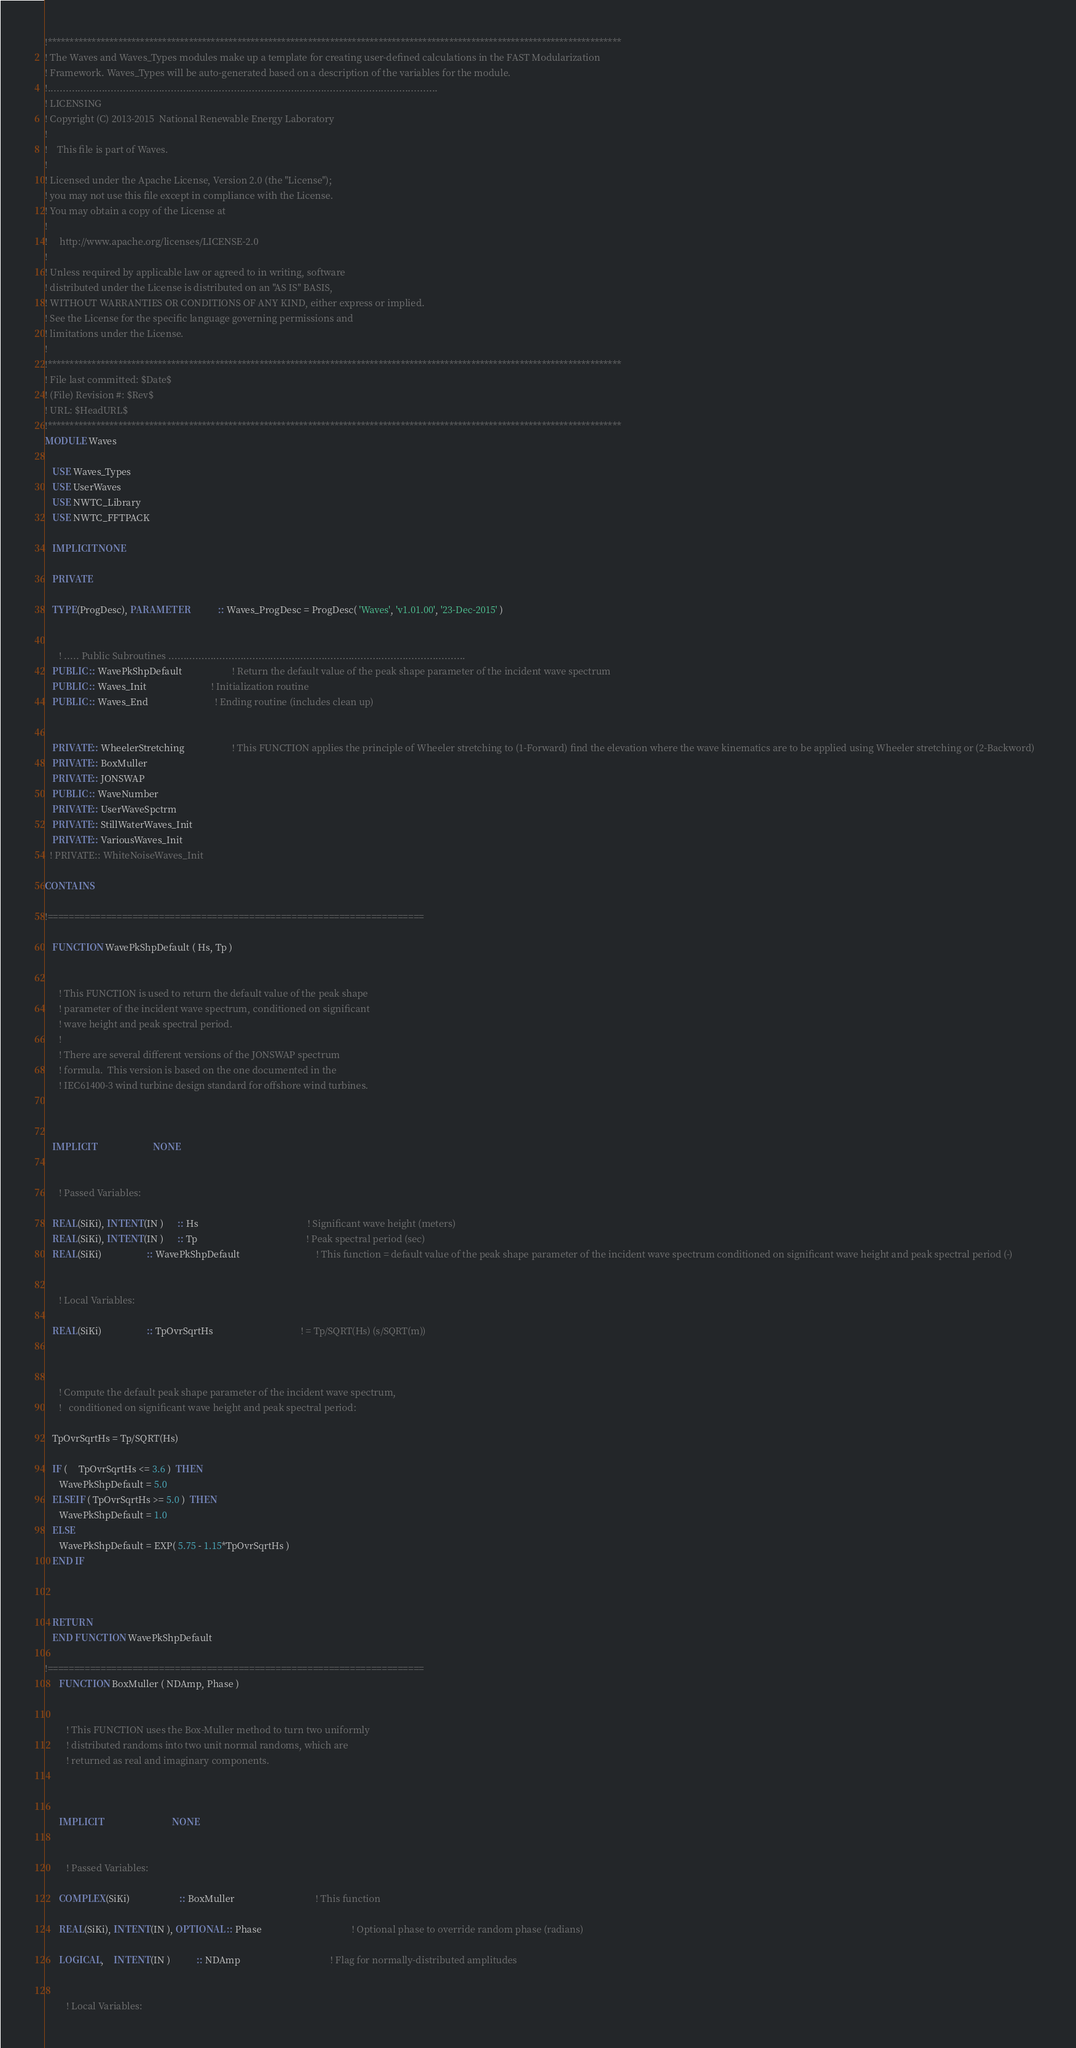<code> <loc_0><loc_0><loc_500><loc_500><_FORTRAN_>!**********************************************************************************************************************************
! The Waves and Waves_Types modules make up a template for creating user-defined calculations in the FAST Modularization 
! Framework. Waves_Types will be auto-generated based on a description of the variables for the module.
!..................................................................................................................................
! LICENSING
! Copyright (C) 2013-2015  National Renewable Energy Laboratory
!
!    This file is part of Waves.
!
! Licensed under the Apache License, Version 2.0 (the "License");
! you may not use this file except in compliance with the License.
! You may obtain a copy of the License at
!
!     http://www.apache.org/licenses/LICENSE-2.0
!
! Unless required by applicable law or agreed to in writing, software
! distributed under the License is distributed on an "AS IS" BASIS,
! WITHOUT WARRANTIES OR CONDITIONS OF ANY KIND, either express or implied.
! See the License for the specific language governing permissions and
! limitations under the License.
!    
!**********************************************************************************************************************************
! File last committed: $Date$
! (File) Revision #: $Rev$
! URL: $HeadURL$
!**********************************************************************************************************************************
MODULE Waves

   USE Waves_Types  
   USE UserWaves
   USE NWTC_Library
   USE NWTC_FFTPACK
      
   IMPLICIT NONE
   
   PRIVATE

   TYPE(ProgDesc), PARAMETER            :: Waves_ProgDesc = ProgDesc( 'Waves', 'v1.01.00', '23-Dec-2015' )

   
      ! ..... Public Subroutines ...................................................................................................
   PUBLIC :: WavePkShpDefault                     ! Return the default value of the peak shape parameter of the incident wave spectrum
   PUBLIC :: Waves_Init                           ! Initialization routine
   PUBLIC :: Waves_End                            ! Ending routine (includes clean up)
            
   
   PRIVATE:: WheelerStretching                    ! This FUNCTION applies the principle of Wheeler stretching to (1-Forward) find the elevation where the wave kinematics are to be applied using Wheeler stretching or (2-Backword)   
   PRIVATE:: BoxMuller
   PRIVATE:: JONSWAP
   PUBLIC :: WaveNumber
   PRIVATE:: UserWaveSpctrm   
   PRIVATE:: StillWaterWaves_Init
   PRIVATE:: VariousWaves_Init
  ! PRIVATE:: WhiteNoiseWaves_Init

CONTAINS

!=======================================================================

   FUNCTION WavePkShpDefault ( Hs, Tp )


      ! This FUNCTION is used to return the default value of the peak shape
      ! parameter of the incident wave spectrum, conditioned on significant
      ! wave height and peak spectral period.
      !
      ! There are several different versions of the JONSWAP spectrum
      ! formula.  This version is based on the one documented in the
      ! IEC61400-3 wind turbine design standard for offshore wind turbines.



   IMPLICIT                        NONE


      ! Passed Variables:

   REAL(SiKi), INTENT(IN )      :: Hs                                              ! Significant wave height (meters)
   REAL(SiKi), INTENT(IN )      :: Tp                                              ! Peak spectral period (sec)
   REAL(SiKi)                   :: WavePkShpDefault                                ! This function = default value of the peak shape parameter of the incident wave spectrum conditioned on significant wave height and peak spectral period (-)


      ! Local Variables:

   REAL(SiKi)                   :: TpOvrSqrtHs                                     ! = Tp/SQRT(Hs) (s/SQRT(m))



      ! Compute the default peak shape parameter of the incident wave spectrum,
      !   conditioned on significant wave height and peak spectral period:

   TpOvrSqrtHs = Tp/SQRT(Hs)

   IF (     TpOvrSqrtHs <= 3.6 )  THEN
      WavePkShpDefault = 5.0
   ELSEIF ( TpOvrSqrtHs >= 5.0 )  THEN
      WavePkShpDefault = 1.0
   ELSE
      WavePkShpDefault = EXP( 5.75 - 1.15*TpOvrSqrtHs )
   END IF



   RETURN
   END FUNCTION WavePkShpDefault
   
!=======================================================================
      FUNCTION BoxMuller ( NDAmp, Phase )


         ! This FUNCTION uses the Box-Muller method to turn two uniformly
         ! distributed randoms into two unit normal randoms, which are
         ! returned as real and imaginary components.



      IMPLICIT                             NONE


         ! Passed Variables:

      COMPLEX(SiKi)                     :: BoxMuller                                  ! This function

      REAL(SiKi), INTENT(IN ), OPTIONAL :: Phase                                      ! Optional phase to override random phase (radians)

      LOGICAL,    INTENT(IN )           :: NDAmp                                      ! Flag for normally-distributed amplitudes


         ! Local Variables:
</code> 